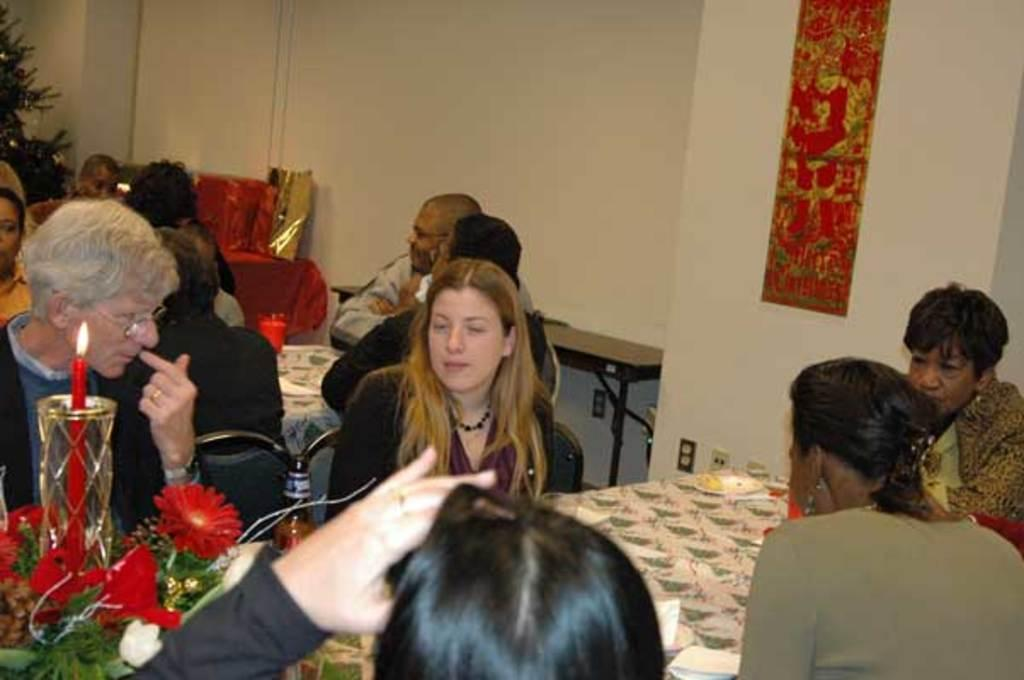What type of structure can be seen in the image? There is a wall in the image. What type of vegetation is present in the image? There is a plant in the image. What are the people in the image doing? There is a group of people sitting on chairs in the image. What type of furniture is present in the image? There are tables in the image. What items can be seen on the tables? There are plates, tissues, candles, and flowers present on the tables. What channel is the group of people watching on the television in the image? There is no television present in the image; it only features a wall, a plant, a group of people sitting on chairs, tables, plates, tissues, candles, and flowers. How many eyes are visible on the people in the image? The number of eyes cannot be determined from the image, as it only shows a group of people sitting on chairs and does not provide a close-up view of their faces. 